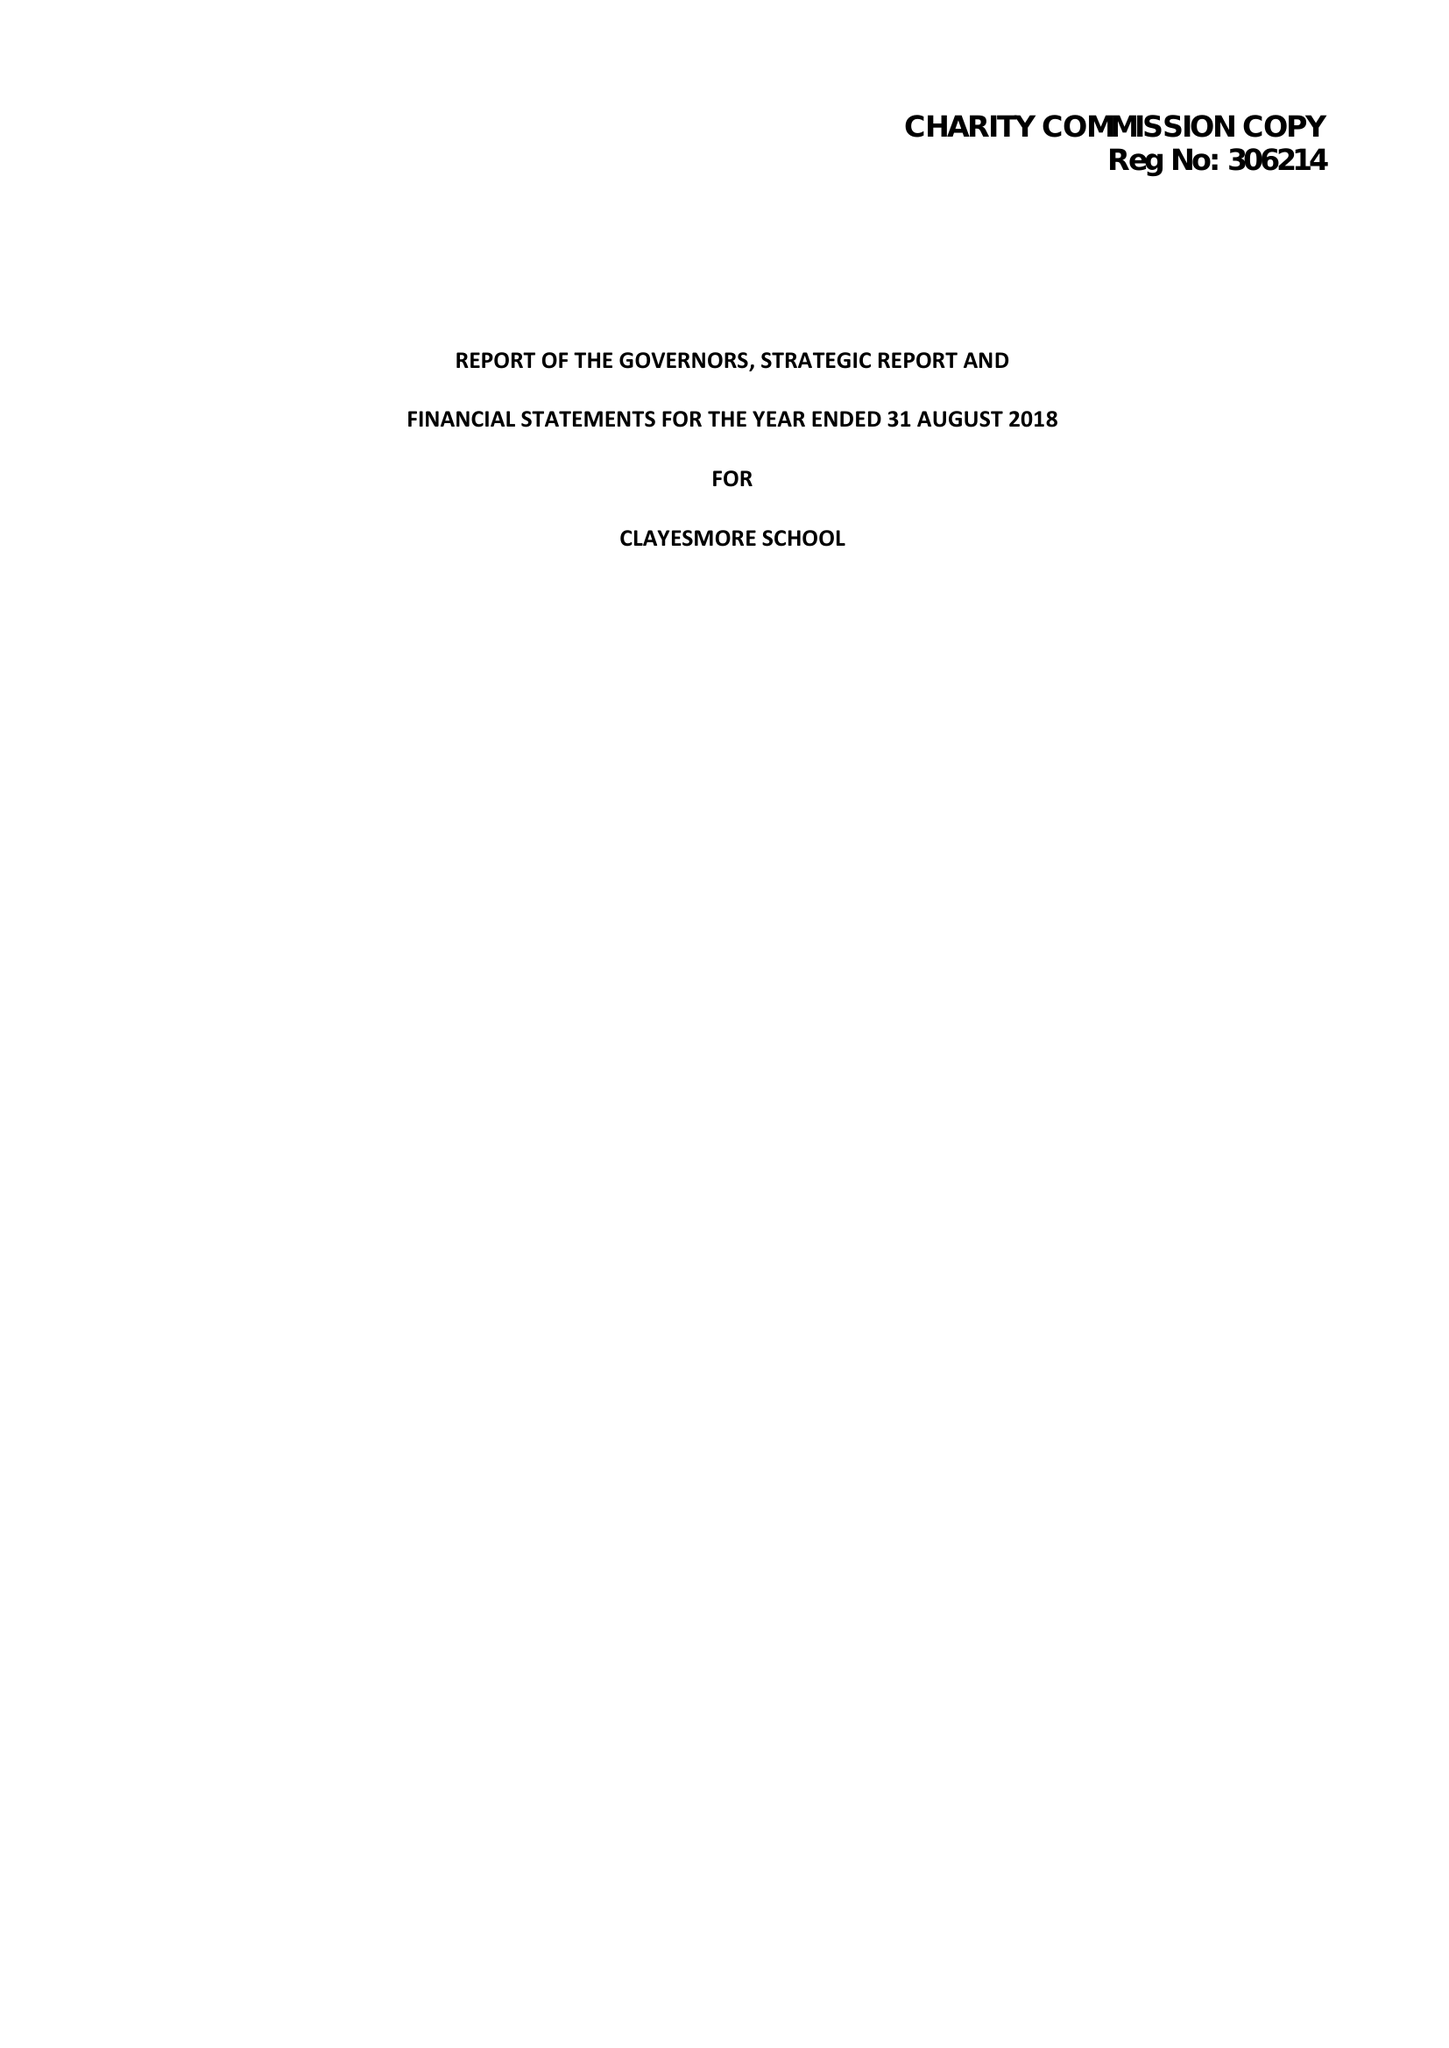What is the value for the charity_number?
Answer the question using a single word or phrase. 306214 